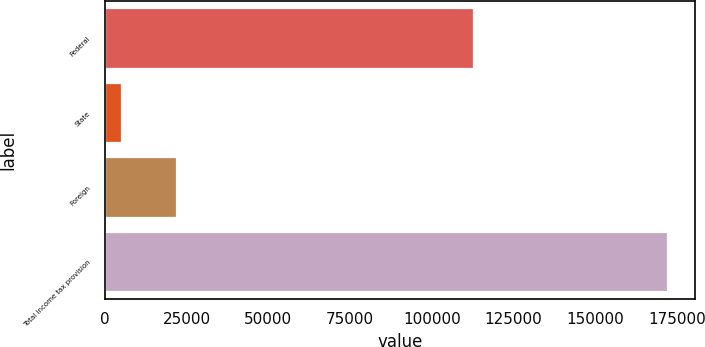<chart> <loc_0><loc_0><loc_500><loc_500><bar_chart><fcel>Federal<fcel>State<fcel>Foreign<fcel>Total income tax provision<nl><fcel>112673<fcel>5035<fcel>21715.7<fcel>171842<nl></chart> 